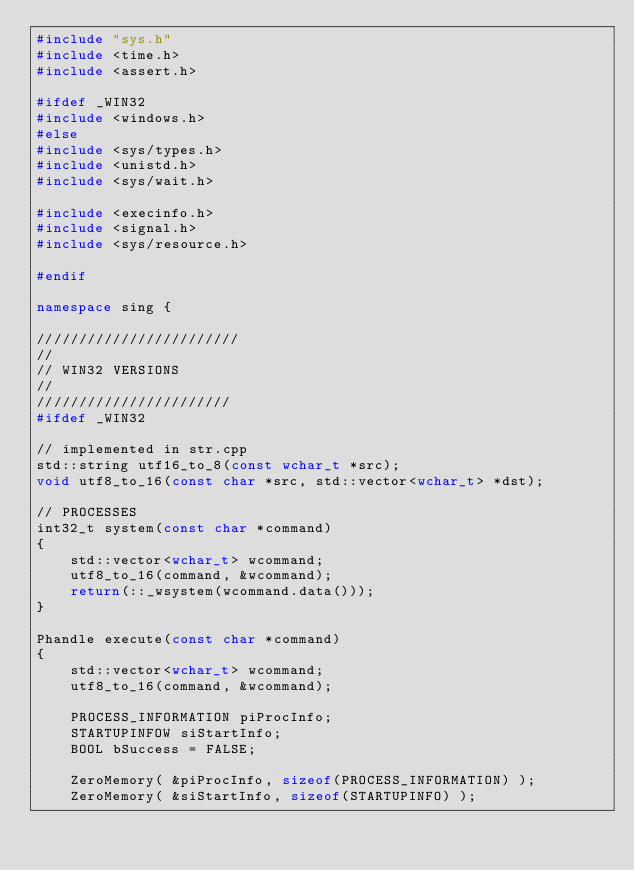<code> <loc_0><loc_0><loc_500><loc_500><_C++_>#include "sys.h"
#include <time.h>
#include <assert.h>

#ifdef _WIN32    
#include <windows.h>
#else
#include <sys/types.h>
#include <unistd.h>
#include <sys/wait.h>

#include <execinfo.h>
#include <signal.h>
#include <sys/resource.h>

#endif

namespace sing {

////////////////////////
//
// WIN32 VERSIONS
//
///////////////////////
#ifdef _WIN32    

// implemented in str.cpp
std::string utf16_to_8(const wchar_t *src);
void utf8_to_16(const char *src, std::vector<wchar_t> *dst);

// PROCESSES
int32_t system(const char *command)
{
    std::vector<wchar_t> wcommand;
    utf8_to_16(command, &wcommand);
    return(::_wsystem(wcommand.data()));
}

Phandle execute(const char *command)
{
    std::vector<wchar_t> wcommand;
    utf8_to_16(command, &wcommand);

    PROCESS_INFORMATION piProcInfo; 
    STARTUPINFOW siStartInfo;
    BOOL bSuccess = FALSE; 
 
    ZeroMemory( &piProcInfo, sizeof(PROCESS_INFORMATION) );
    ZeroMemory( &siStartInfo, sizeof(STARTUPINFO) );</code> 